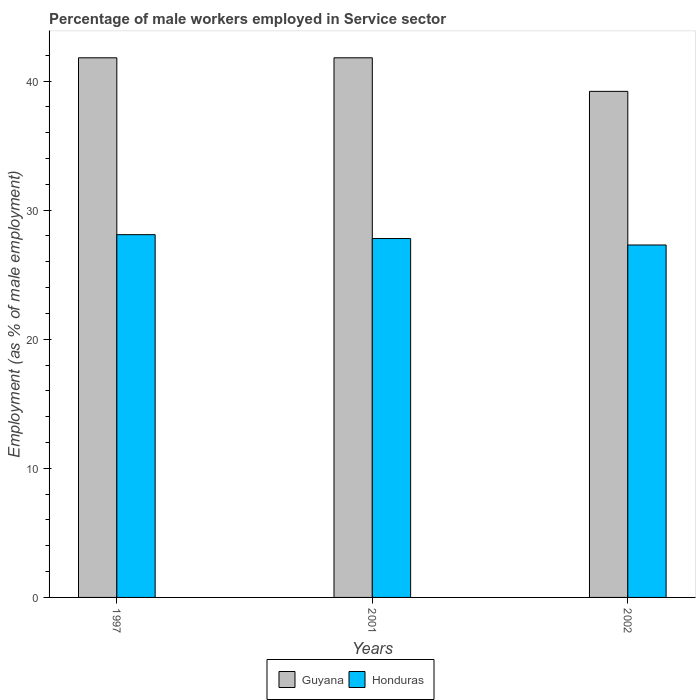How many different coloured bars are there?
Give a very brief answer. 2. Are the number of bars per tick equal to the number of legend labels?
Offer a terse response. Yes. How many bars are there on the 2nd tick from the left?
Make the answer very short. 2. How many bars are there on the 1st tick from the right?
Make the answer very short. 2. What is the label of the 3rd group of bars from the left?
Your answer should be very brief. 2002. What is the percentage of male workers employed in Service sector in Guyana in 1997?
Your response must be concise. 41.8. Across all years, what is the maximum percentage of male workers employed in Service sector in Guyana?
Provide a succinct answer. 41.8. Across all years, what is the minimum percentage of male workers employed in Service sector in Guyana?
Your response must be concise. 39.2. In which year was the percentage of male workers employed in Service sector in Guyana minimum?
Provide a short and direct response. 2002. What is the total percentage of male workers employed in Service sector in Guyana in the graph?
Provide a short and direct response. 122.8. What is the difference between the percentage of male workers employed in Service sector in Guyana in 1997 and that in 2002?
Provide a short and direct response. 2.6. What is the difference between the percentage of male workers employed in Service sector in Honduras in 1997 and the percentage of male workers employed in Service sector in Guyana in 2001?
Offer a very short reply. -13.7. What is the average percentage of male workers employed in Service sector in Honduras per year?
Give a very brief answer. 27.73. In the year 1997, what is the difference between the percentage of male workers employed in Service sector in Honduras and percentage of male workers employed in Service sector in Guyana?
Ensure brevity in your answer.  -13.7. In how many years, is the percentage of male workers employed in Service sector in Guyana greater than 12 %?
Make the answer very short. 3. What is the ratio of the percentage of male workers employed in Service sector in Honduras in 1997 to that in 2002?
Your response must be concise. 1.03. Is the difference between the percentage of male workers employed in Service sector in Honduras in 2001 and 2002 greater than the difference between the percentage of male workers employed in Service sector in Guyana in 2001 and 2002?
Offer a terse response. No. What is the difference between the highest and the second highest percentage of male workers employed in Service sector in Honduras?
Keep it short and to the point. 0.3. What is the difference between the highest and the lowest percentage of male workers employed in Service sector in Honduras?
Provide a succinct answer. 0.8. What does the 1st bar from the left in 1997 represents?
Your answer should be very brief. Guyana. What does the 2nd bar from the right in 2001 represents?
Keep it short and to the point. Guyana. What is the difference between two consecutive major ticks on the Y-axis?
Your answer should be very brief. 10. Does the graph contain any zero values?
Provide a short and direct response. No. Does the graph contain grids?
Give a very brief answer. No. How are the legend labels stacked?
Your response must be concise. Horizontal. What is the title of the graph?
Keep it short and to the point. Percentage of male workers employed in Service sector. What is the label or title of the X-axis?
Give a very brief answer. Years. What is the label or title of the Y-axis?
Your answer should be very brief. Employment (as % of male employment). What is the Employment (as % of male employment) of Guyana in 1997?
Give a very brief answer. 41.8. What is the Employment (as % of male employment) in Honduras in 1997?
Make the answer very short. 28.1. What is the Employment (as % of male employment) of Guyana in 2001?
Keep it short and to the point. 41.8. What is the Employment (as % of male employment) of Honduras in 2001?
Offer a very short reply. 27.8. What is the Employment (as % of male employment) in Guyana in 2002?
Provide a short and direct response. 39.2. What is the Employment (as % of male employment) of Honduras in 2002?
Give a very brief answer. 27.3. Across all years, what is the maximum Employment (as % of male employment) of Guyana?
Give a very brief answer. 41.8. Across all years, what is the maximum Employment (as % of male employment) in Honduras?
Provide a short and direct response. 28.1. Across all years, what is the minimum Employment (as % of male employment) of Guyana?
Your answer should be very brief. 39.2. Across all years, what is the minimum Employment (as % of male employment) of Honduras?
Keep it short and to the point. 27.3. What is the total Employment (as % of male employment) in Guyana in the graph?
Offer a very short reply. 122.8. What is the total Employment (as % of male employment) of Honduras in the graph?
Your response must be concise. 83.2. What is the difference between the Employment (as % of male employment) in Guyana in 1997 and that in 2001?
Offer a very short reply. 0. What is the difference between the Employment (as % of male employment) of Guyana in 2001 and that in 2002?
Make the answer very short. 2.6. What is the difference between the Employment (as % of male employment) of Guyana in 1997 and the Employment (as % of male employment) of Honduras in 2001?
Keep it short and to the point. 14. What is the difference between the Employment (as % of male employment) in Guyana in 2001 and the Employment (as % of male employment) in Honduras in 2002?
Keep it short and to the point. 14.5. What is the average Employment (as % of male employment) in Guyana per year?
Provide a short and direct response. 40.93. What is the average Employment (as % of male employment) of Honduras per year?
Keep it short and to the point. 27.73. In the year 1997, what is the difference between the Employment (as % of male employment) of Guyana and Employment (as % of male employment) of Honduras?
Ensure brevity in your answer.  13.7. What is the ratio of the Employment (as % of male employment) of Honduras in 1997 to that in 2001?
Provide a short and direct response. 1.01. What is the ratio of the Employment (as % of male employment) of Guyana in 1997 to that in 2002?
Provide a succinct answer. 1.07. What is the ratio of the Employment (as % of male employment) of Honduras in 1997 to that in 2002?
Provide a short and direct response. 1.03. What is the ratio of the Employment (as % of male employment) of Guyana in 2001 to that in 2002?
Your answer should be compact. 1.07. What is the ratio of the Employment (as % of male employment) of Honduras in 2001 to that in 2002?
Your answer should be very brief. 1.02. What is the difference between the highest and the second highest Employment (as % of male employment) in Honduras?
Provide a short and direct response. 0.3. What is the difference between the highest and the lowest Employment (as % of male employment) in Guyana?
Your answer should be very brief. 2.6. What is the difference between the highest and the lowest Employment (as % of male employment) in Honduras?
Provide a short and direct response. 0.8. 